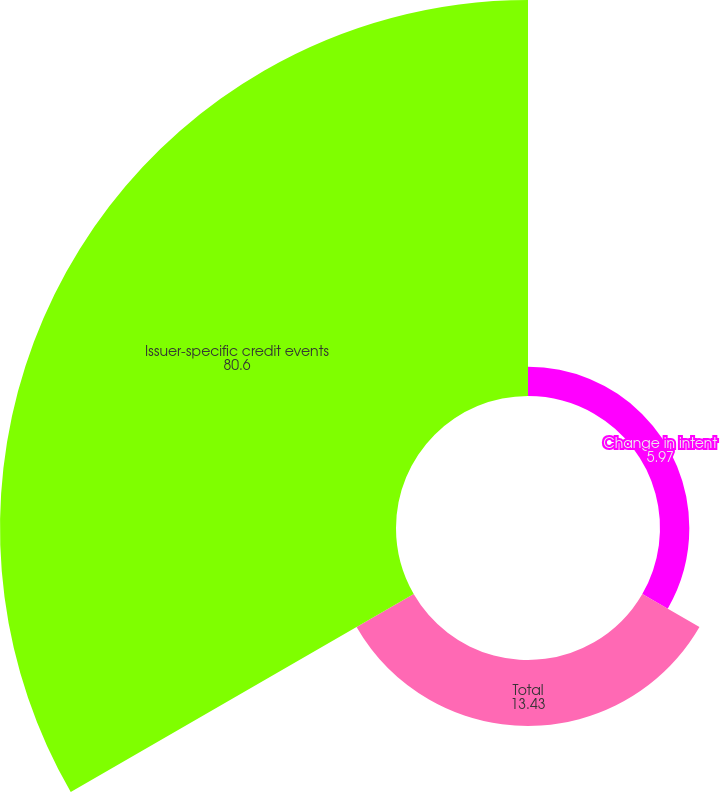Convert chart to OTSL. <chart><loc_0><loc_0><loc_500><loc_500><pie_chart><fcel>Change in intent<fcel>Total<fcel>Issuer-specific credit events<nl><fcel>5.97%<fcel>13.43%<fcel>80.6%<nl></chart> 